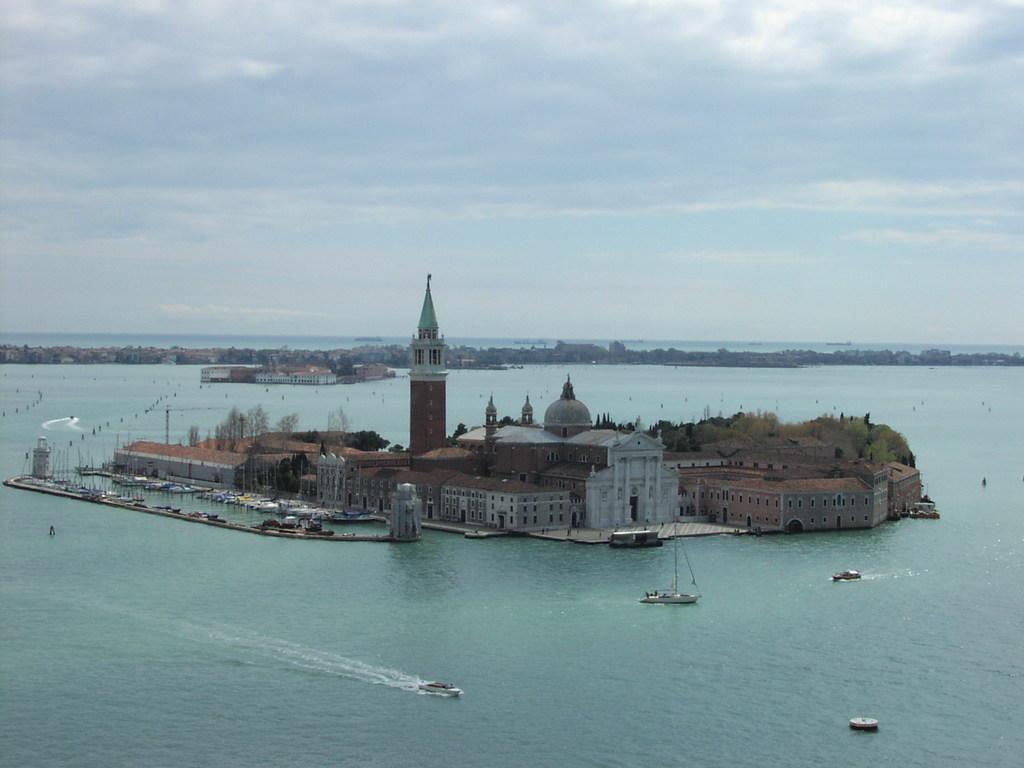What type of structures can be seen in the image? There are buildings in the image. What other objects are present in the image? There are poles, ships, and boats in the image. What type of vegetation is visible in the image? There is grass in the image. What part of the natural environment is visible in the image? The sky is visible in the image, and clouds are present in the sky. What type of water body is visible in the image? There is water visible in the image. What type of ring can be seen on the finger of the person in the image? There is no person present in the image, and therefore no ring can be seen. What is the plot of the story being told in the image? The image does not depict a story or plot; it is a collection of objects and structures. 